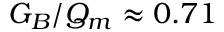<formula> <loc_0><loc_0><loc_500><loc_500>G _ { B } / Q _ { m } \approx 0 . 7 1</formula> 